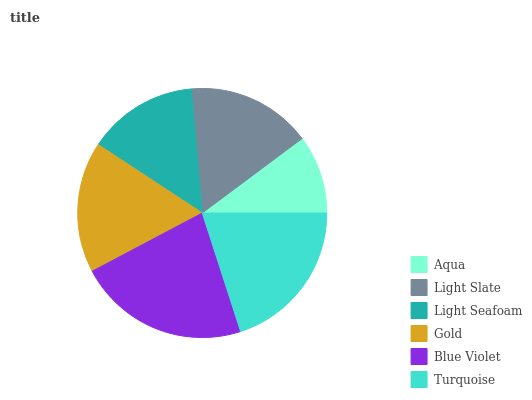Is Aqua the minimum?
Answer yes or no. Yes. Is Blue Violet the maximum?
Answer yes or no. Yes. Is Light Slate the minimum?
Answer yes or no. No. Is Light Slate the maximum?
Answer yes or no. No. Is Light Slate greater than Aqua?
Answer yes or no. Yes. Is Aqua less than Light Slate?
Answer yes or no. Yes. Is Aqua greater than Light Slate?
Answer yes or no. No. Is Light Slate less than Aqua?
Answer yes or no. No. Is Gold the high median?
Answer yes or no. Yes. Is Light Slate the low median?
Answer yes or no. Yes. Is Light Seafoam the high median?
Answer yes or no. No. Is Turquoise the low median?
Answer yes or no. No. 